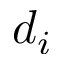Convert formula to latex. <formula><loc_0><loc_0><loc_500><loc_500>d _ { i }</formula> 